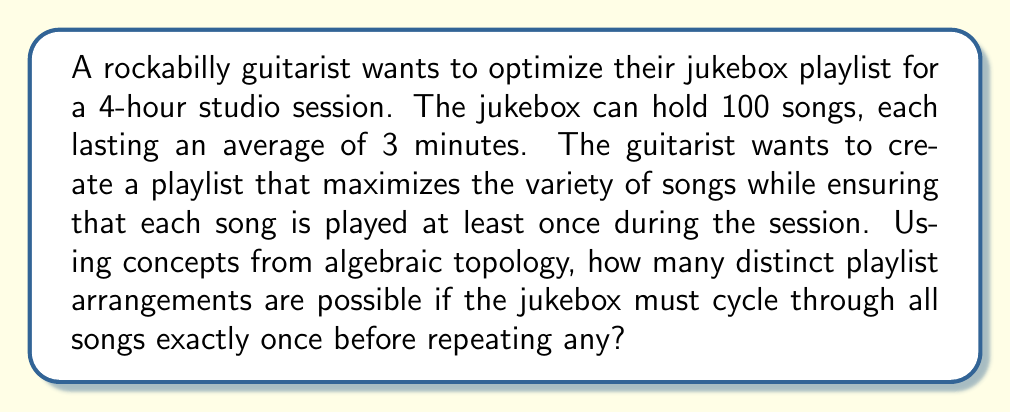Provide a solution to this math problem. Let's approach this step-by-step using concepts from algebraic topology:

1) First, we need to determine how many songs can be played in the 4-hour session:
   4 hours = 240 minutes
   Number of songs that can be played = 240 / 3 = 80 songs

2) We can represent the playlist as a path on a simplicial complex, where each vertex represents a song, and edges represent transitions between songs.

3) The problem of creating a playlist that cycles through all songs exactly once before repeating is equivalent to finding a Hamiltonian cycle on this simplicial complex.

4) The number of distinct Hamiltonian cycles on a complete graph with n vertices is given by the formula:

   $$(n-1)! / 2$$

5) In this case, n = 80 (the number of songs that can be played in the session)

6) Therefore, the number of distinct playlist arrangements is:

   $$(80-1)! / 2 = 79! / 2$$

7) This can be simplified to:

   $$\frac{1}{2} \times 79 \times 78 \times 77 \times ... \times 3 \times 2 \times 1$$

8) This number is extremely large and can be expressed in scientific notation as approximately:

   $$1.1863 \times 10^{118}$$
Answer: $$1.1863 \times 10^{118}$$ 